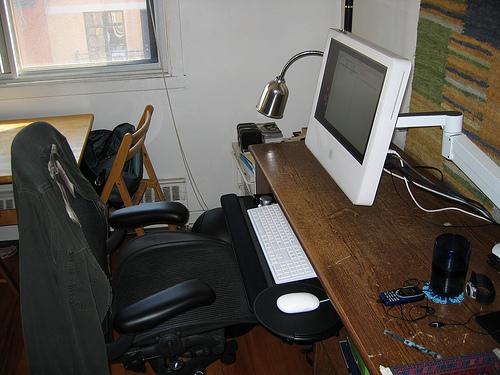Are there any religious figurines in the picture?
Quick response, please. No. What type of equipment is in the photo?
Concise answer only. Computer. What color is the keyboard?
Be succinct. White. Is the screen turned on?
Quick response, please. Yes. Is the screen sitting on the desk?
Quick response, please. No. 